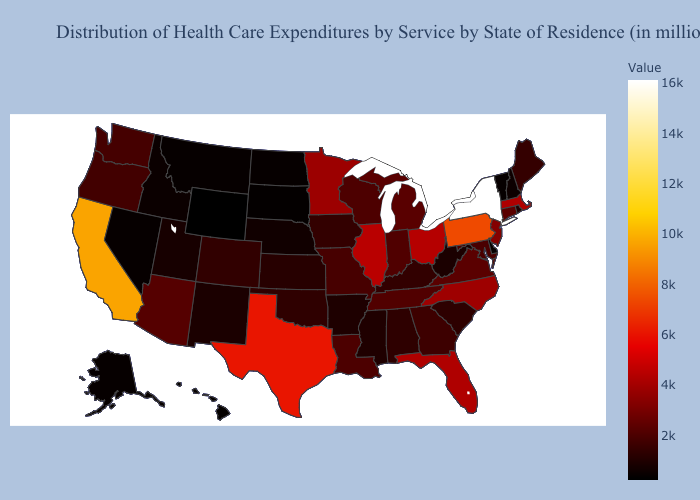Among the states that border New Jersey , does Pennsylvania have the highest value?
Be succinct. No. Does the map have missing data?
Give a very brief answer. No. Which states have the lowest value in the USA?
Be succinct. Wyoming. Does Illinois have the lowest value in the MidWest?
Give a very brief answer. No. Does California have the highest value in the West?
Write a very short answer. Yes. Is the legend a continuous bar?
Quick response, please. Yes. Does New Jersey have the lowest value in the USA?
Give a very brief answer. No. Does the map have missing data?
Write a very short answer. No. 